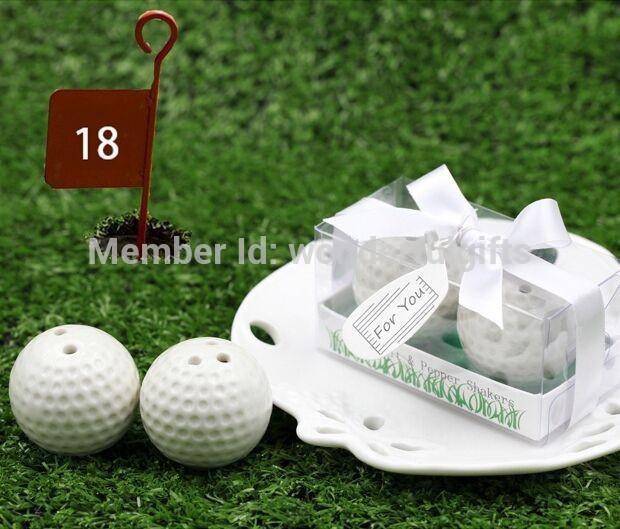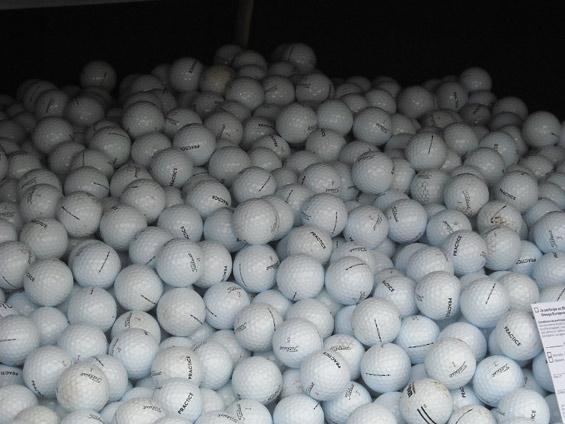The first image is the image on the left, the second image is the image on the right. Given the left and right images, does the statement "One image shows gift wrapped golf balls." hold true? Answer yes or no. Yes. The first image is the image on the left, the second image is the image on the right. Analyze the images presented: Is the assertion "Multiple people are standing on green grass in one of the golf-themed images." valid? Answer yes or no. No. 